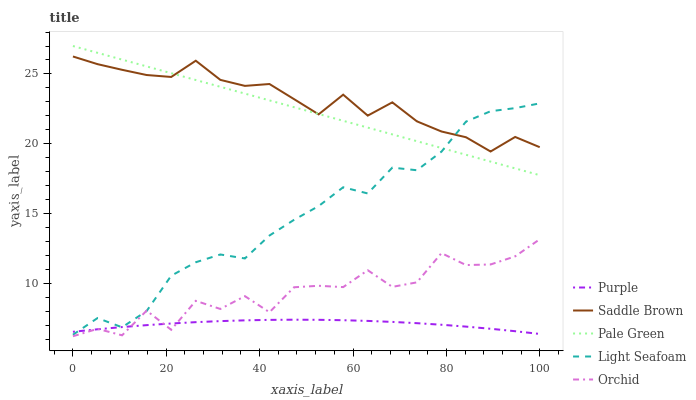Does Purple have the minimum area under the curve?
Answer yes or no. Yes. Does Saddle Brown have the maximum area under the curve?
Answer yes or no. Yes. Does Pale Green have the minimum area under the curve?
Answer yes or no. No. Does Pale Green have the maximum area under the curve?
Answer yes or no. No. Is Pale Green the smoothest?
Answer yes or no. Yes. Is Orchid the roughest?
Answer yes or no. Yes. Is Saddle Brown the smoothest?
Answer yes or no. No. Is Saddle Brown the roughest?
Answer yes or no. No. Does Orchid have the lowest value?
Answer yes or no. Yes. Does Pale Green have the lowest value?
Answer yes or no. No. Does Pale Green have the highest value?
Answer yes or no. Yes. Does Saddle Brown have the highest value?
Answer yes or no. No. Is Purple less than Pale Green?
Answer yes or no. Yes. Is Saddle Brown greater than Purple?
Answer yes or no. Yes. Does Pale Green intersect Saddle Brown?
Answer yes or no. Yes. Is Pale Green less than Saddle Brown?
Answer yes or no. No. Is Pale Green greater than Saddle Brown?
Answer yes or no. No. Does Purple intersect Pale Green?
Answer yes or no. No. 